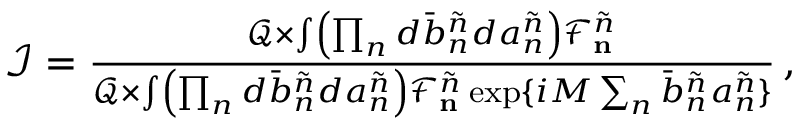<formula> <loc_0><loc_0><loc_500><loc_500>\begin{array} { r } { \mathcal { I } = \frac { \mathcal { Q } \times \int \left ( \prod _ { n } d \bar { b } _ { n } ^ { \tilde { n } } d a _ { n } ^ { \tilde { n } } \right ) \mathcal { F } _ { n } ^ { \tilde { n } } } { \mathcal { Q } \times \int \left ( \prod _ { n } d \bar { b } _ { n } ^ { \tilde { n } } d a _ { n } ^ { \tilde { n } } \right ) \mathcal { F } _ { n } ^ { \tilde { n } } \exp \{ i M \sum _ { n } \bar { b } _ { n } ^ { \tilde { n } } a _ { n } ^ { \tilde { n } } \} } \, , } \end{array}</formula> 